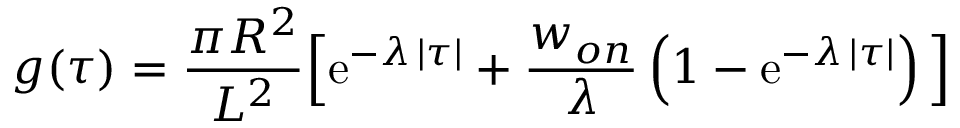Convert formula to latex. <formula><loc_0><loc_0><loc_500><loc_500>g ( \tau ) = { \frac { \pi R ^ { 2 } } { L ^ { 2 } } } \left [ e ^ { - \lambda \, | \tau | } + { \frac { w _ { o n } } { \lambda } } \left ( 1 - e ^ { - \lambda \, | \tau | } \right ) \right ]</formula> 